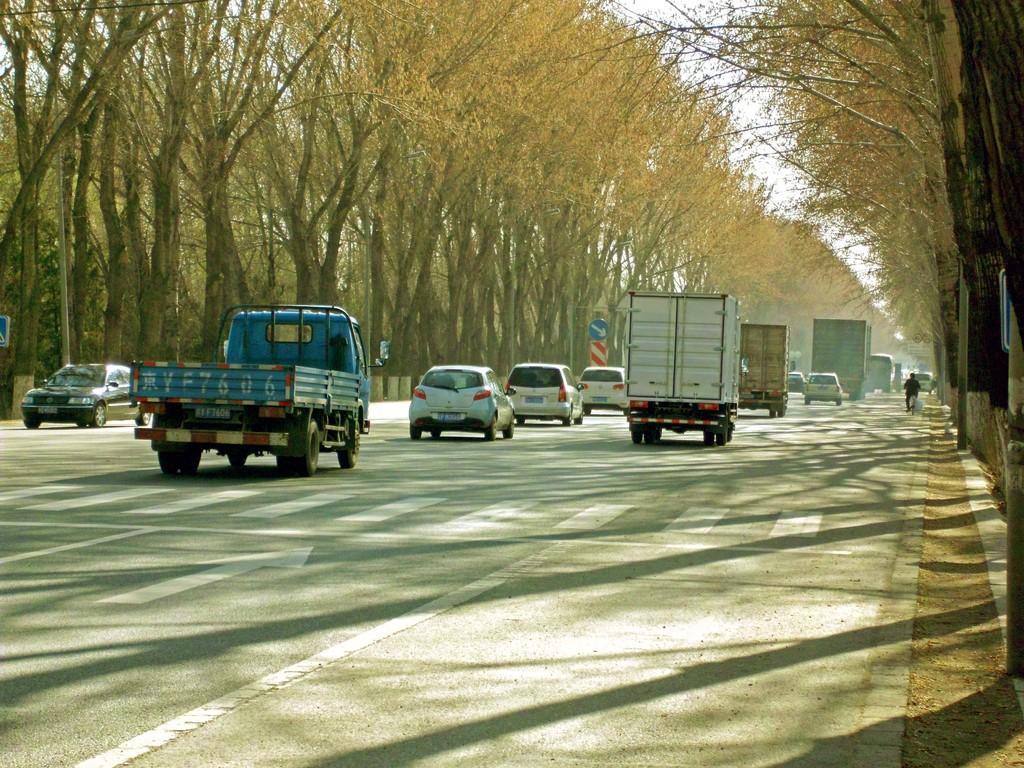In one or two sentences, can you explain what this image depicts? In the picture we can see the road on it, we can see some vehicles and besides the road we can see trees and on the top of the trees we can see the part of the sky. 